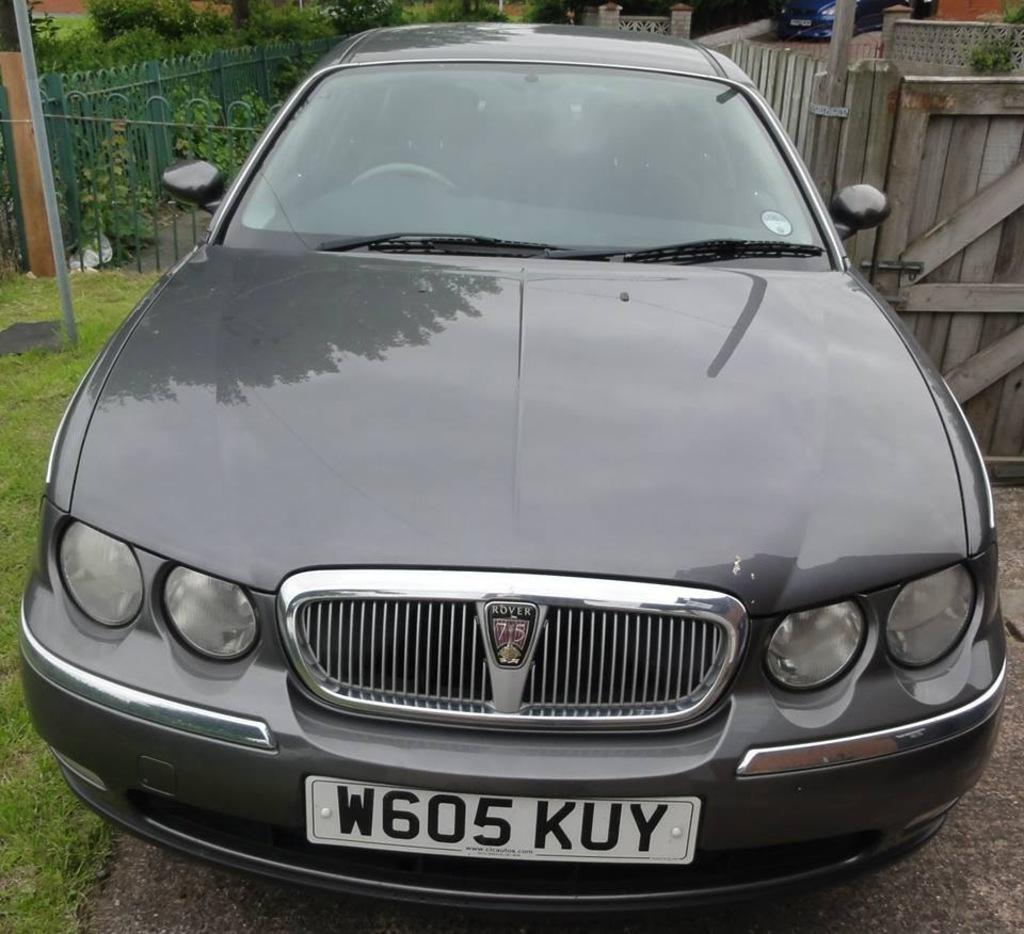<image>
Summarize the visual content of the image. The grey Rover car has a license plate that says, 'W605 KUY'. 